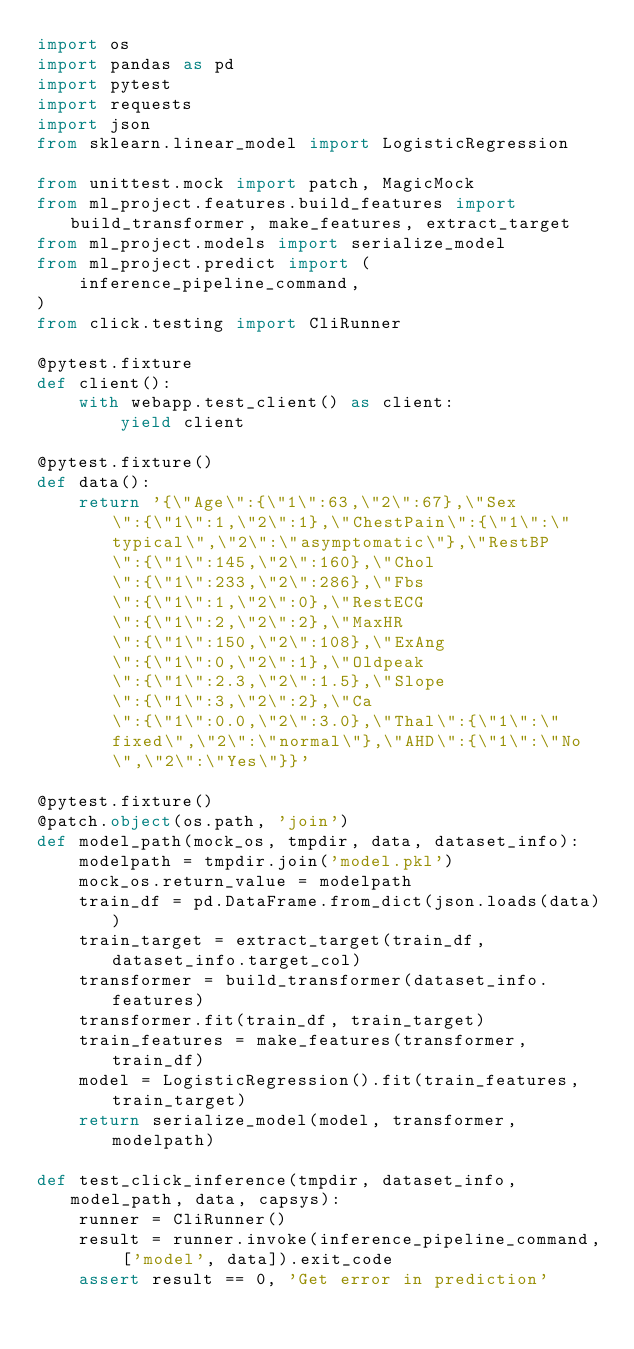Convert code to text. <code><loc_0><loc_0><loc_500><loc_500><_Python_>import os
import pandas as pd
import pytest
import requests
import json
from sklearn.linear_model import LogisticRegression

from unittest.mock import patch, MagicMock
from ml_project.features.build_features import build_transformer, make_features, extract_target
from ml_project.models import serialize_model
from ml_project.predict import (
    inference_pipeline_command,
)
from click.testing import CliRunner

@pytest.fixture
def client():
    with webapp.test_client() as client:
        yield client
        
@pytest.fixture()
def data():
    return '{\"Age\":{\"1\":63,\"2\":67},\"Sex\":{\"1\":1,\"2\":1},\"ChestPain\":{\"1\":\"typical\",\"2\":\"asymptomatic\"},\"RestBP\":{\"1\":145,\"2\":160},\"Chol\":{\"1\":233,\"2\":286},\"Fbs\":{\"1\":1,\"2\":0},\"RestECG\":{\"1\":2,\"2\":2},\"MaxHR\":{\"1\":150,\"2\":108},\"ExAng\":{\"1\":0,\"2\":1},\"Oldpeak\":{\"1\":2.3,\"2\":1.5},\"Slope\":{\"1\":3,\"2\":2},\"Ca\":{\"1\":0.0,\"2\":3.0},\"Thal\":{\"1\":\"fixed\",\"2\":\"normal\"},\"AHD\":{\"1\":\"No\",\"2\":\"Yes\"}}'

@pytest.fixture()
@patch.object(os.path, 'join')
def model_path(mock_os, tmpdir, data, dataset_info):
    modelpath = tmpdir.join('model.pkl')
    mock_os.return_value = modelpath
    train_df = pd.DataFrame.from_dict(json.loads(data))
    train_target = extract_target(train_df, dataset_info.target_col)
    transformer = build_transformer(dataset_info.features)
    transformer.fit(train_df, train_target)
    train_features = make_features(transformer, train_df)
    model = LogisticRegression().fit(train_features, train_target)
    return serialize_model(model, transformer, modelpath)
    
def test_click_inference(tmpdir, dataset_info, model_path, data, capsys):
    runner = CliRunner()
    result = runner.invoke(inference_pipeline_command, ['model', data]).exit_code
    assert result == 0, 'Get error in prediction'</code> 